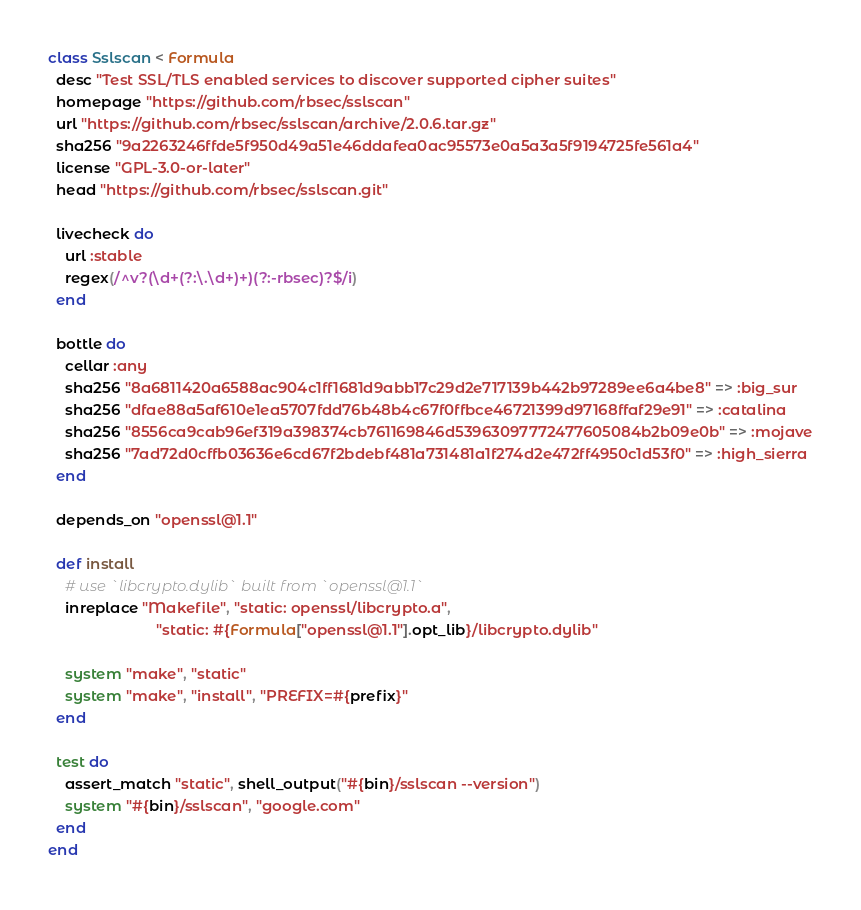<code> <loc_0><loc_0><loc_500><loc_500><_Ruby_>class Sslscan < Formula
  desc "Test SSL/TLS enabled services to discover supported cipher suites"
  homepage "https://github.com/rbsec/sslscan"
  url "https://github.com/rbsec/sslscan/archive/2.0.6.tar.gz"
  sha256 "9a2263246ffde5f950d49a51e46ddafea0ac95573e0a5a3a5f9194725fe561a4"
  license "GPL-3.0-or-later"
  head "https://github.com/rbsec/sslscan.git"

  livecheck do
    url :stable
    regex(/^v?(\d+(?:\.\d+)+)(?:-rbsec)?$/i)
  end

  bottle do
    cellar :any
    sha256 "8a6811420a6588ac904c1ff1681d9abb17c29d2e717139b442b97289ee6a4be8" => :big_sur
    sha256 "dfae88a5af610e1ea5707fdd76b48b4c67f0ffbce46721399d97168ffaf29e91" => :catalina
    sha256 "8556ca9cab96ef319a398374cb761169846d53963097772477605084b2b09e0b" => :mojave
    sha256 "7ad72d0cffb03636e6cd67f2bdebf481a731481a1f274d2e472ff4950c1d53f0" => :high_sierra
  end

  depends_on "openssl@1.1"

  def install
    # use `libcrypto.dylib` built from `openssl@1.1`
    inreplace "Makefile", "static: openssl/libcrypto.a",
                          "static: #{Formula["openssl@1.1"].opt_lib}/libcrypto.dylib"

    system "make", "static"
    system "make", "install", "PREFIX=#{prefix}"
  end

  test do
    assert_match "static", shell_output("#{bin}/sslscan --version")
    system "#{bin}/sslscan", "google.com"
  end
end
</code> 